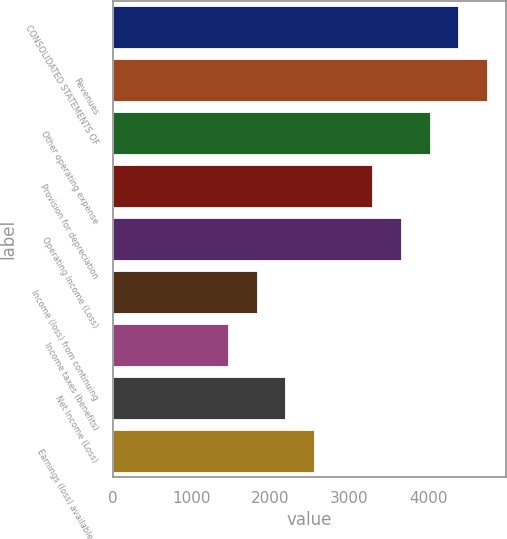<chart> <loc_0><loc_0><loc_500><loc_500><bar_chart><fcel>CONSOLIDATED STATEMENTS OF<fcel>Revenues<fcel>Other operating expense<fcel>Provision for depreciation<fcel>Operating Income (Loss)<fcel>Income (loss) from continuing<fcel>Income taxes (benefits)<fcel>Net Income (Loss)<fcel>Earnings (loss) available to<nl><fcel>4376.38<fcel>4741.05<fcel>4011.71<fcel>3282.37<fcel>3647.04<fcel>1823.69<fcel>1459.02<fcel>2188.36<fcel>2553.03<nl></chart> 